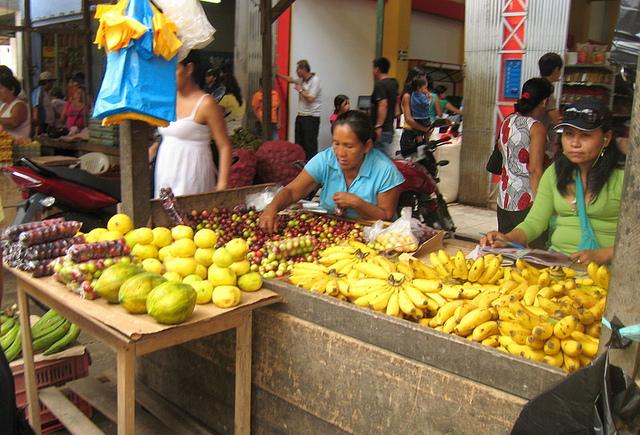Where is the woman's hands?
Give a very brief answer. On fruit. Is the weather cold?
Keep it brief. No. Is this a regular store?
Be succinct. No. What kind of stand is this?
Keep it brief. Fruit. Which fruit is in front of the flowers?
Short answer required. Bananas. Why is the woman sit on a cushion?
Be succinct. Working. Which fruit is typically peeled and enjoyed?
Keep it brief. Banana. 